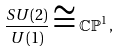Convert formula to latex. <formula><loc_0><loc_0><loc_500><loc_500>\frac { S U ( 2 ) } { U ( 1 ) } \cong \mathbb { C P } ^ { 1 } \, ,</formula> 